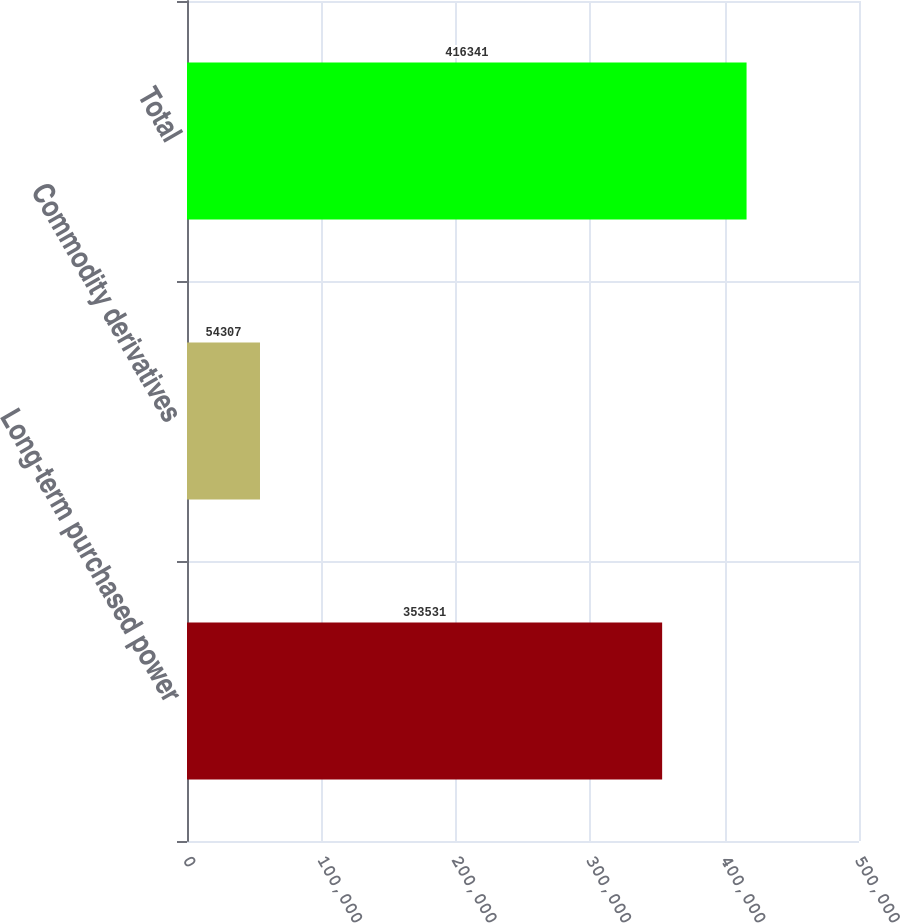<chart> <loc_0><loc_0><loc_500><loc_500><bar_chart><fcel>Long-term purchased power<fcel>Commodity derivatives<fcel>Total<nl><fcel>353531<fcel>54307<fcel>416341<nl></chart> 